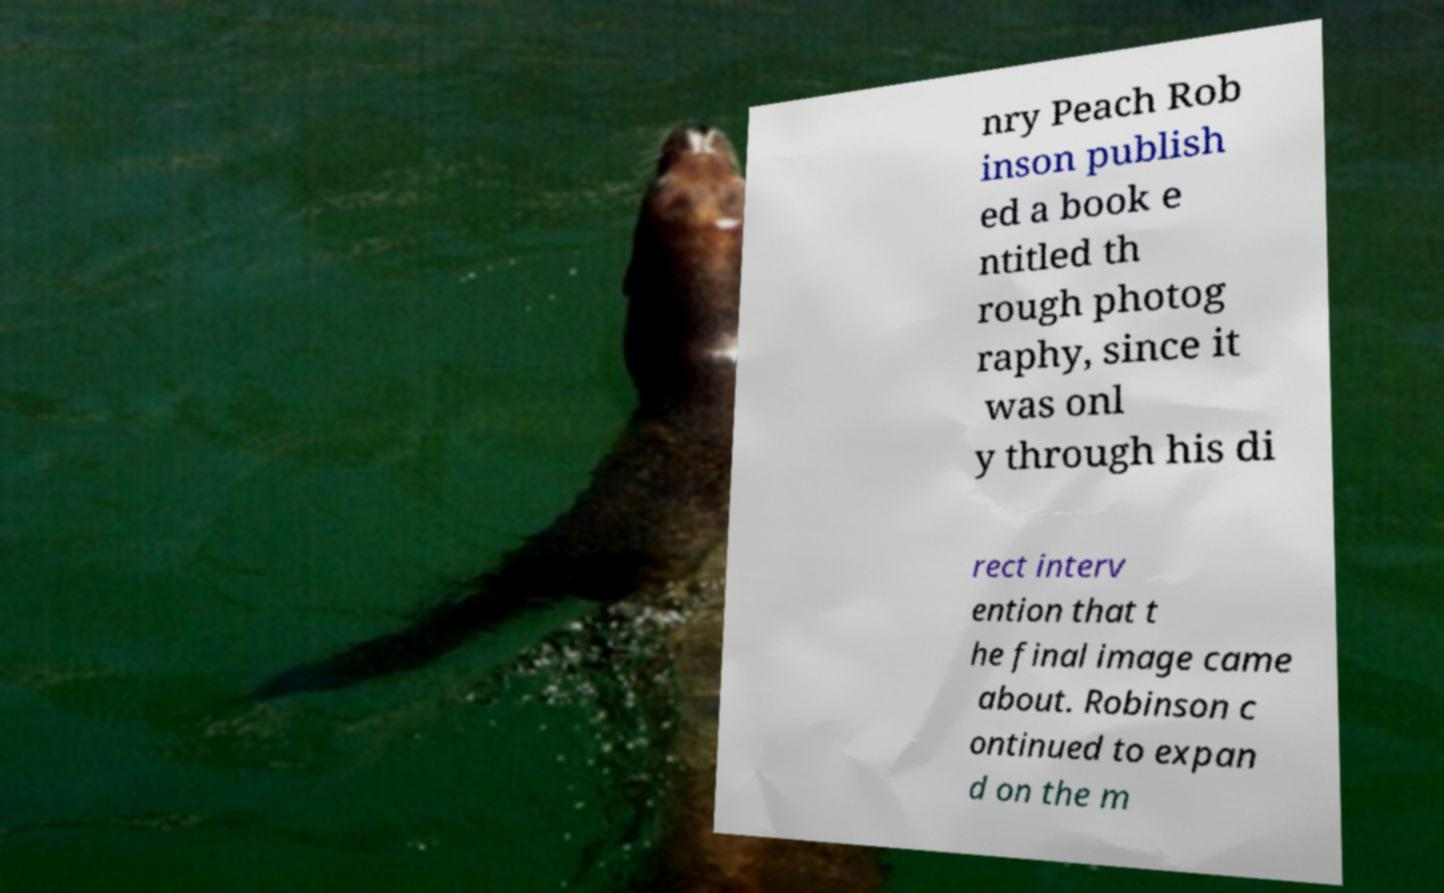There's text embedded in this image that I need extracted. Can you transcribe it verbatim? nry Peach Rob inson publish ed a book e ntitled th rough photog raphy, since it was onl y through his di rect interv ention that t he final image came about. Robinson c ontinued to expan d on the m 